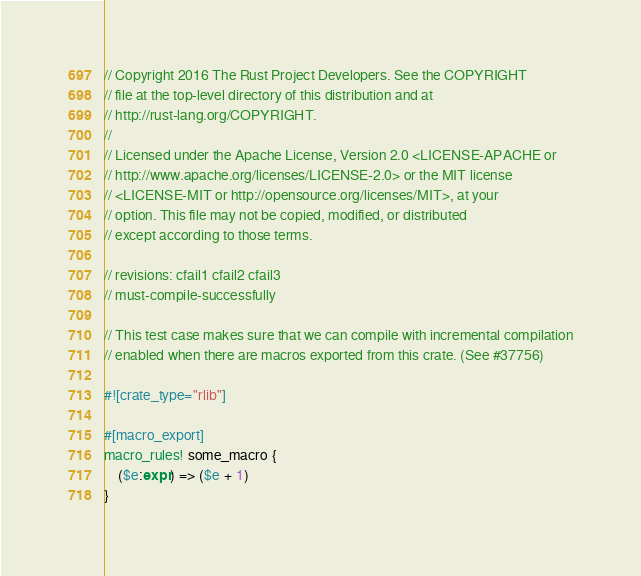<code> <loc_0><loc_0><loc_500><loc_500><_Rust_>// Copyright 2016 The Rust Project Developers. See the COPYRIGHT
// file at the top-level directory of this distribution and at
// http://rust-lang.org/COPYRIGHT.
//
// Licensed under the Apache License, Version 2.0 <LICENSE-APACHE or
// http://www.apache.org/licenses/LICENSE-2.0> or the MIT license
// <LICENSE-MIT or http://opensource.org/licenses/MIT>, at your
// option. This file may not be copied, modified, or distributed
// except according to those terms.

// revisions: cfail1 cfail2 cfail3
// must-compile-successfully

// This test case makes sure that we can compile with incremental compilation
// enabled when there are macros exported from this crate. (See #37756)

#![crate_type="rlib"]

#[macro_export]
macro_rules! some_macro {
    ($e:expr) => ($e + 1)
}
</code> 